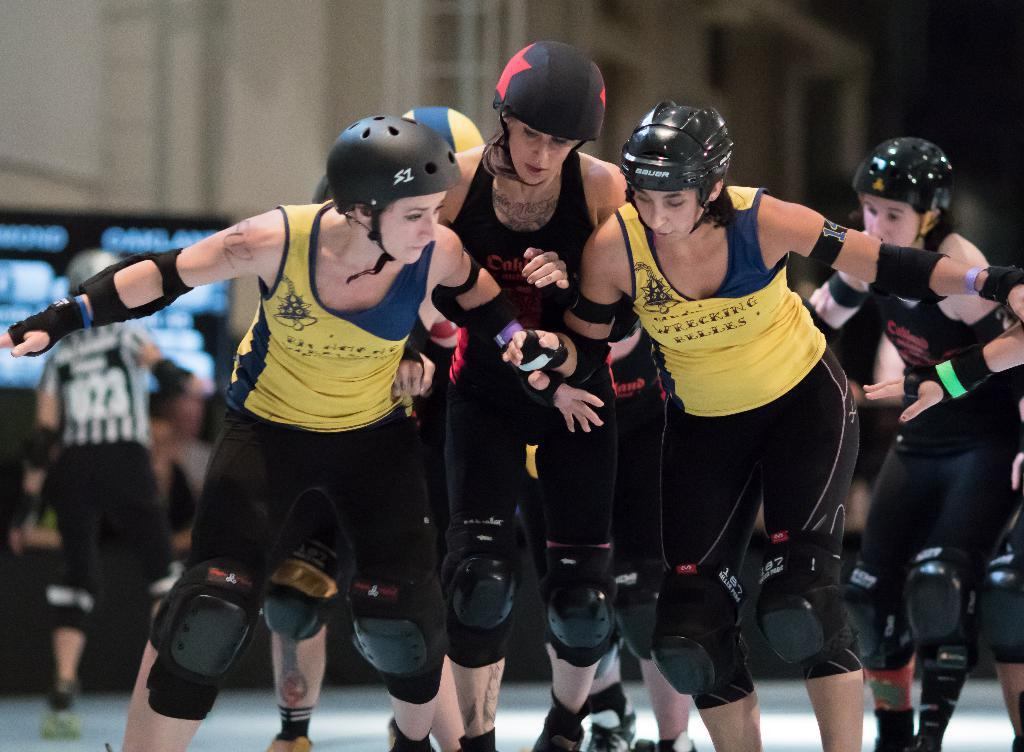What are the persons in the image wearing on their heads? The persons in the image are wearing helmets. Can you describe the person in the background of the image? There is a person in the background of the image, but no specific details about them are provided. What can be seen in the background of the image besides the person? There is a board and a building in the background of the image. What type of discovery is being made by the group in the image? There is no group present in the image, and no discovery is being made. 